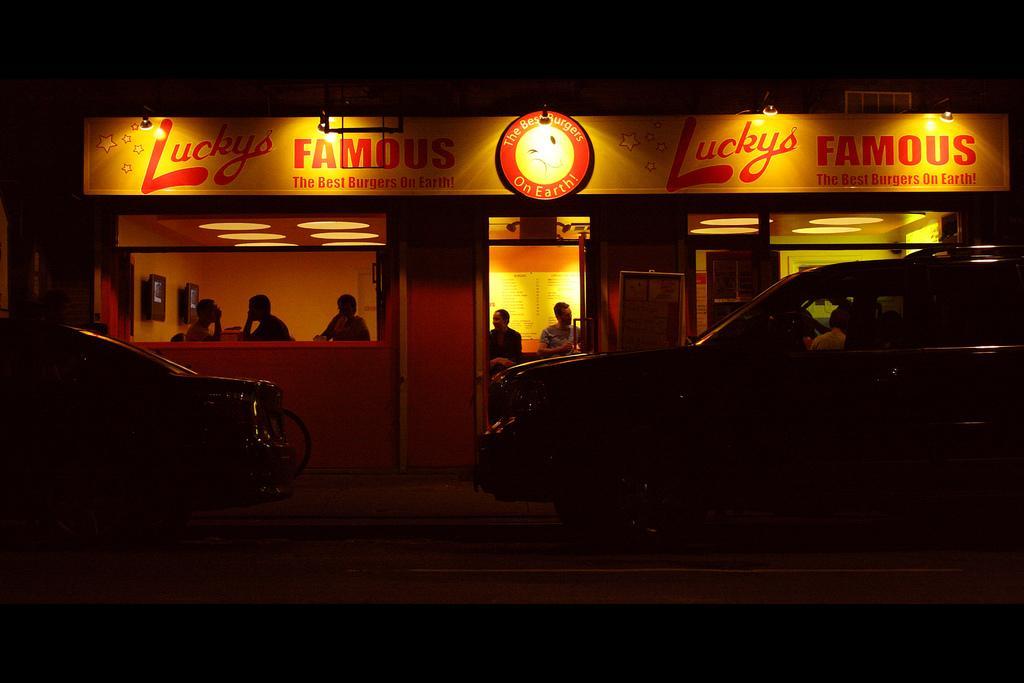Please provide a concise description of this image. In the image it is a burger cafe,there are some people sitting inside the cafe, to the wall there is a menu,outside the restaurant there are two cars,the background is dark because it is night. 